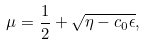Convert formula to latex. <formula><loc_0><loc_0><loc_500><loc_500>\mu = \frac { 1 } { 2 } + \sqrt { \eta - c _ { 0 } \epsilon } ,</formula> 